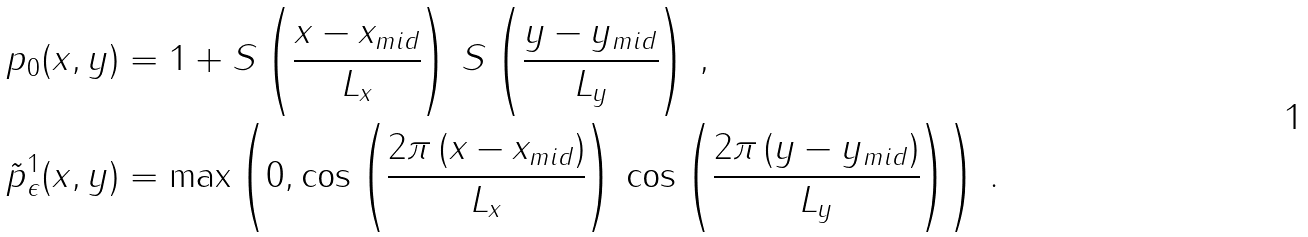Convert formula to latex. <formula><loc_0><loc_0><loc_500><loc_500>p _ { 0 } ( x , y ) & = 1 + S \left ( \cfrac { x - x _ { m i d } } { L _ { x } } \right ) \, S \left ( \cfrac { y - y _ { m i d } } { L _ { y } } \right ) \, , \\ \tilde { p } _ { \epsilon } ^ { 1 } ( x , y ) & = \max \left ( 0 , \cos \left ( \cfrac { 2 \pi \, ( x - x _ { m i d } ) } { L _ { x } } \right ) \, \cos \left ( \cfrac { 2 \pi \, ( y - y _ { m i d } ) } { L _ { y } } \right ) \right ) \, .</formula> 